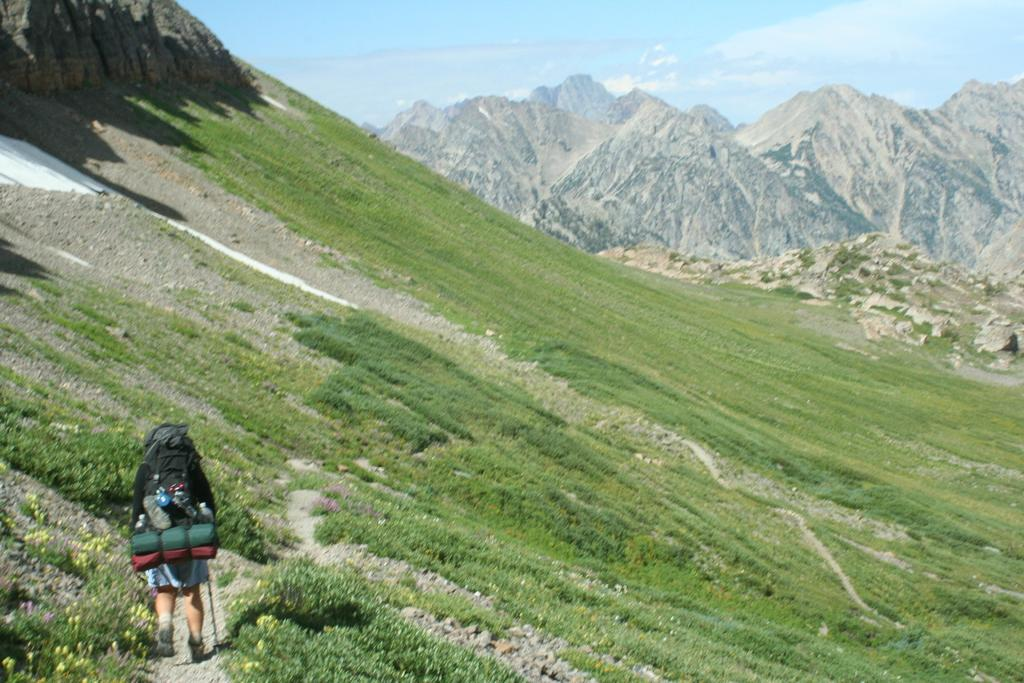What is the main subject of the image? There is a person standing in the image. What is the person holding or carrying? The person is carrying a bag and other objects. What can be seen in the background of the image? There are mountains, grass, and the sky visible in the background of the image. What time of day is it during the morning recess in the image? There is no mention of morning recess or any specific time of day in the image. 